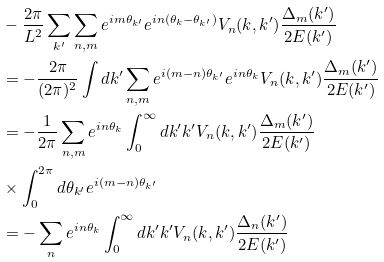<formula> <loc_0><loc_0><loc_500><loc_500>& - \frac { 2 \pi } { L ^ { 2 } } \sum _ { k ^ { \prime } } \sum _ { n , m } e ^ { i m \theta _ { k ^ { \prime } } } e ^ { i n ( \theta _ { k } - \theta _ { k ^ { \prime } } ) } V _ { n } ( k , k ^ { \prime } ) \frac { \Delta _ { m } ( k ^ { \prime } ) } { 2 E ( k ^ { \prime } ) } \\ & = - \frac { 2 \pi } { ( 2 \pi ) ^ { 2 } } \int d { k ^ { \prime } } \sum _ { n , m } e ^ { i ( m - n ) \theta _ { k ^ { \prime } } } e ^ { i n \theta _ { k } } V _ { n } ( k , k ^ { \prime } ) \frac { \Delta _ { m } ( k ^ { \prime } ) } { 2 E ( k ^ { \prime } ) } \\ & = - \frac { 1 } { 2 \pi } \sum _ { n , m } e ^ { i n \theta _ { k } } \int _ { 0 } ^ { \infty } d k ^ { \prime } k ^ { \prime } V _ { n } ( k , k ^ { \prime } ) \frac { \Delta _ { m } ( k ^ { \prime } ) } { 2 E ( k ^ { \prime } ) } \\ & \times \int _ { 0 } ^ { 2 \pi } d \theta _ { k ^ { \prime } } e ^ { i ( m - n ) \theta _ { k ^ { \prime } } } \\ & = - \sum _ { n } e ^ { i n \theta _ { k } } \int _ { 0 } ^ { \infty } d k ^ { \prime } k ^ { \prime } V _ { n } ( k , k ^ { \prime } ) \frac { \Delta _ { n } ( k ^ { \prime } ) } { 2 E ( k ^ { \prime } ) } \\</formula> 